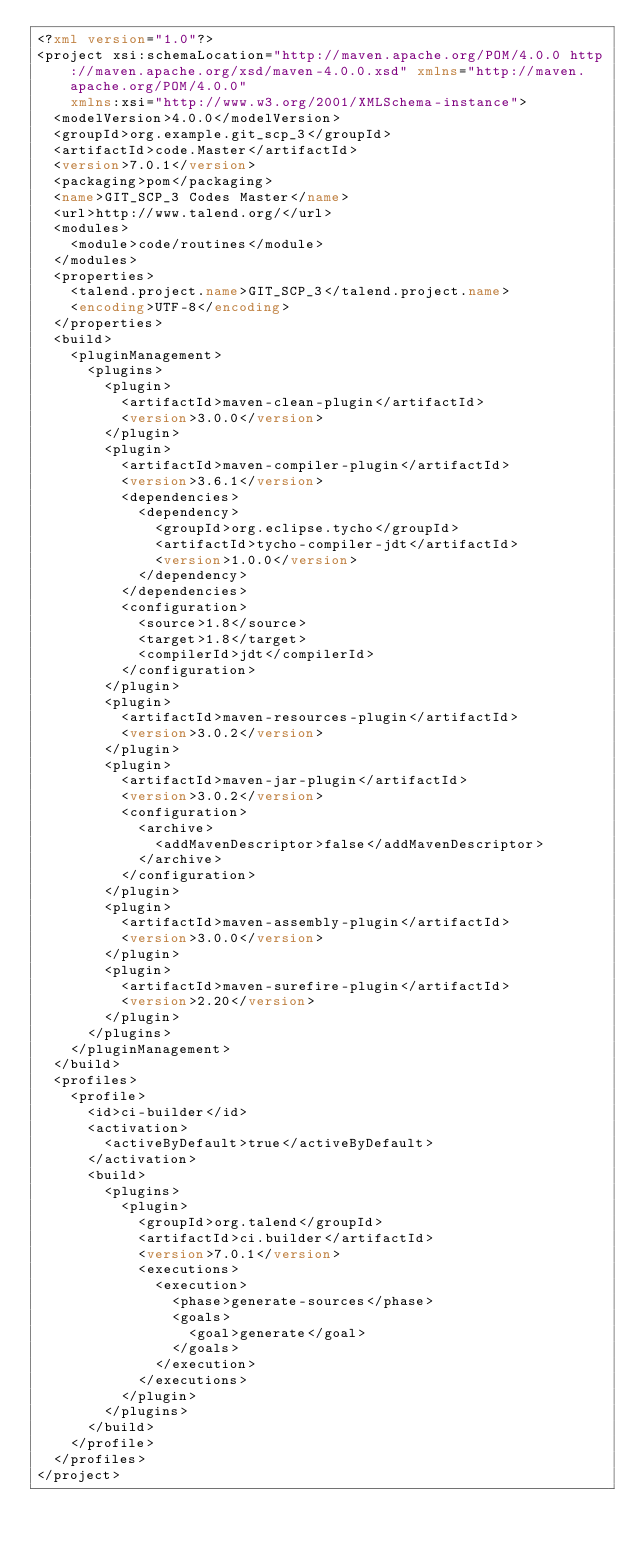Convert code to text. <code><loc_0><loc_0><loc_500><loc_500><_XML_><?xml version="1.0"?>
<project xsi:schemaLocation="http://maven.apache.org/POM/4.0.0 http://maven.apache.org/xsd/maven-4.0.0.xsd" xmlns="http://maven.apache.org/POM/4.0.0"
    xmlns:xsi="http://www.w3.org/2001/XMLSchema-instance">
  <modelVersion>4.0.0</modelVersion>
  <groupId>org.example.git_scp_3</groupId>
  <artifactId>code.Master</artifactId>
  <version>7.0.1</version>
  <packaging>pom</packaging>
  <name>GIT_SCP_3 Codes Master</name>
  <url>http://www.talend.org/</url>
  <modules>
    <module>code/routines</module>
  </modules>
  <properties>
    <talend.project.name>GIT_SCP_3</talend.project.name>
    <encoding>UTF-8</encoding>
  </properties>
  <build>
    <pluginManagement>
      <plugins>
        <plugin>
          <artifactId>maven-clean-plugin</artifactId>
          <version>3.0.0</version>
        </plugin>
        <plugin>
          <artifactId>maven-compiler-plugin</artifactId>
          <version>3.6.1</version>
          <dependencies>
            <dependency>
              <groupId>org.eclipse.tycho</groupId>
              <artifactId>tycho-compiler-jdt</artifactId>
              <version>1.0.0</version>
            </dependency>
          </dependencies>
          <configuration>
            <source>1.8</source>
            <target>1.8</target>
            <compilerId>jdt</compilerId>
          </configuration>
        </plugin>
        <plugin>
          <artifactId>maven-resources-plugin</artifactId>
          <version>3.0.2</version>
        </plugin>
        <plugin>
          <artifactId>maven-jar-plugin</artifactId>
          <version>3.0.2</version>
          <configuration>
            <archive>
              <addMavenDescriptor>false</addMavenDescriptor>
            </archive>
          </configuration>
        </plugin>
        <plugin>
          <artifactId>maven-assembly-plugin</artifactId>
          <version>3.0.0</version>
        </plugin>
        <plugin>
          <artifactId>maven-surefire-plugin</artifactId>
          <version>2.20</version>
        </plugin>
      </plugins>
    </pluginManagement>
  </build>
  <profiles>
    <profile>
      <id>ci-builder</id>
      <activation>
        <activeByDefault>true</activeByDefault>
      </activation>
      <build>
        <plugins>
          <plugin>
            <groupId>org.talend</groupId>
            <artifactId>ci.builder</artifactId>
            <version>7.0.1</version>
            <executions>
              <execution>
                <phase>generate-sources</phase>
                <goals>
                  <goal>generate</goal>
                </goals>
              </execution>
            </executions>
          </plugin>
        </plugins>
      </build>
    </profile>
  </profiles>
</project>
</code> 